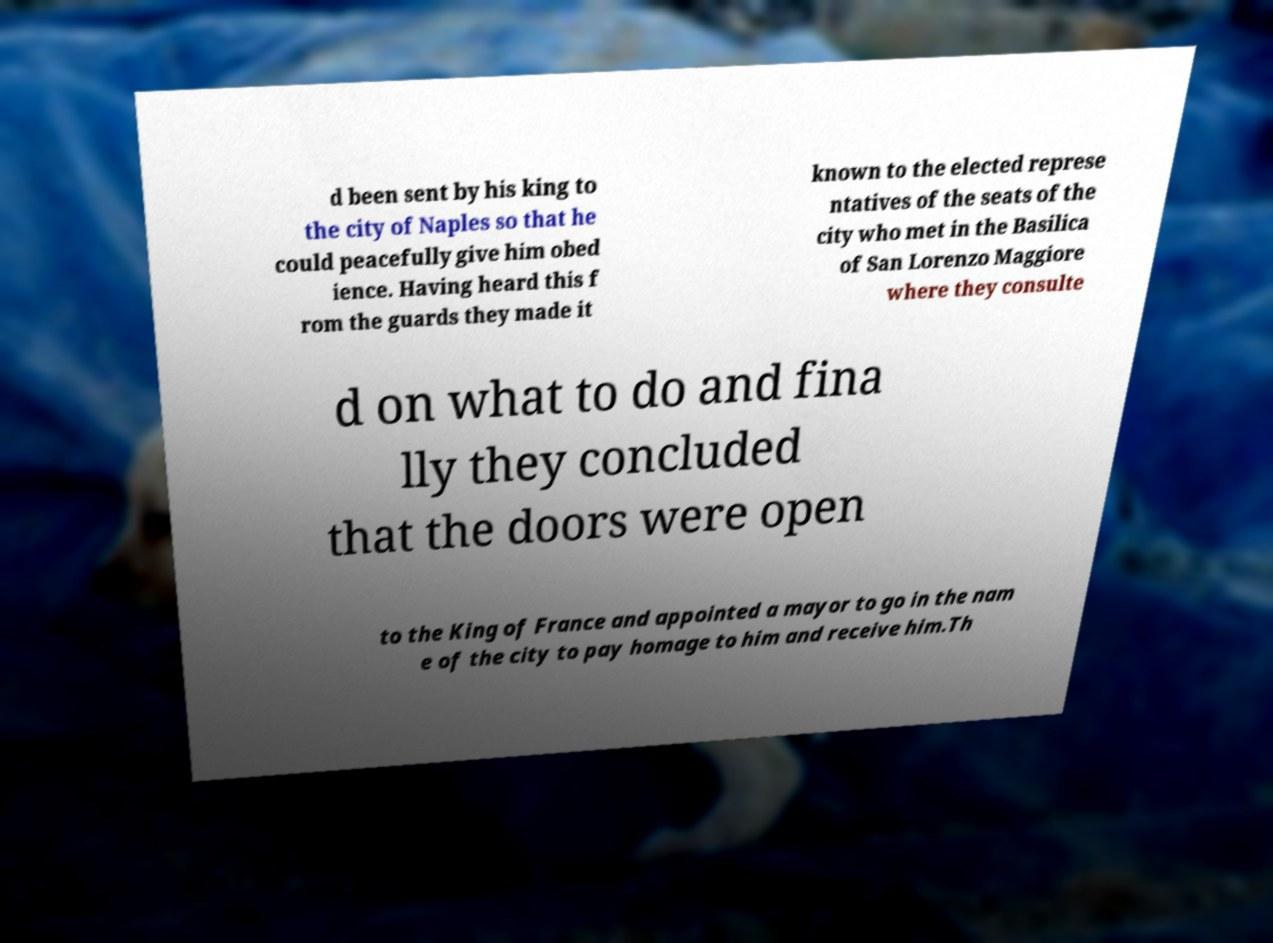There's text embedded in this image that I need extracted. Can you transcribe it verbatim? d been sent by his king to the city of Naples so that he could peacefully give him obed ience. Having heard this f rom the guards they made it known to the elected represe ntatives of the seats of the city who met in the Basilica of San Lorenzo Maggiore where they consulte d on what to do and fina lly they concluded that the doors were open to the King of France and appointed a mayor to go in the nam e of the city to pay homage to him and receive him.Th 